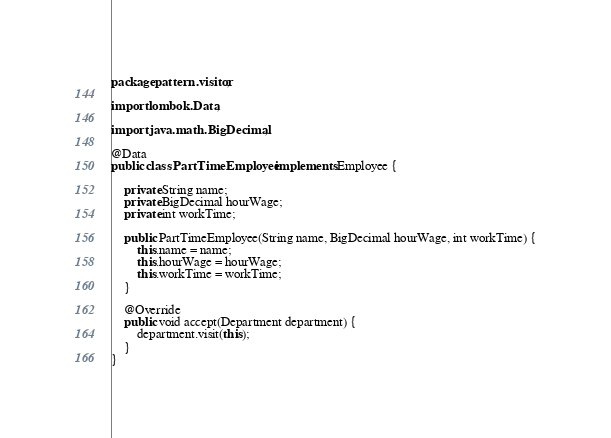<code> <loc_0><loc_0><loc_500><loc_500><_Java_>package pattern.visitor;

import lombok.Data;

import java.math.BigDecimal;

@Data
public class PartTimeEmployee implements Employee {

    private String name;
    private BigDecimal hourWage;
    private int workTime;

    public PartTimeEmployee(String name, BigDecimal hourWage, int workTime) {
        this.name = name;
        this.hourWage = hourWage;
        this.workTime = workTime;
    }

    @Override
    public void accept(Department department) {
        department.visit(this);
    }
}
</code> 